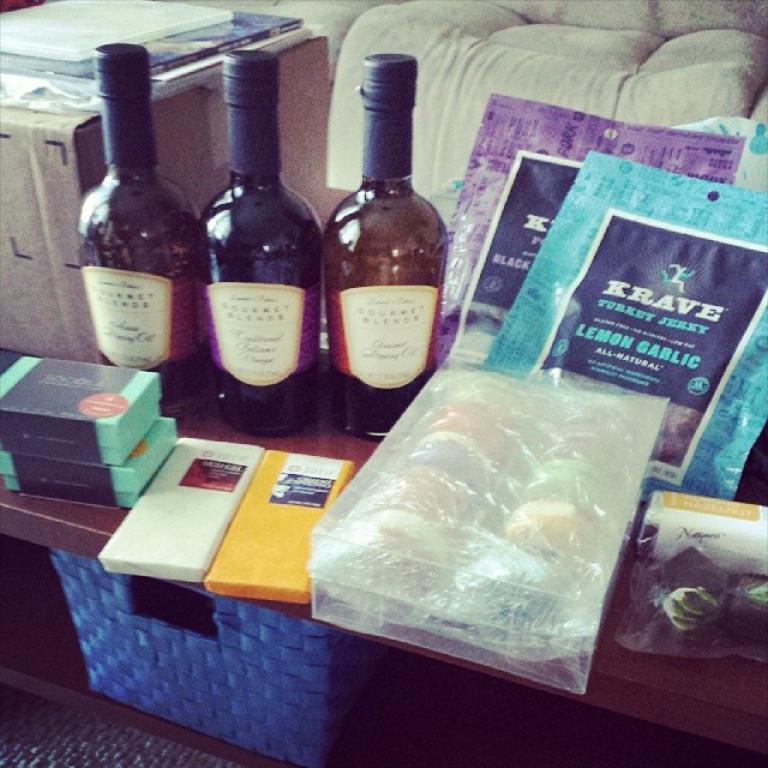<image>
Present a compact description of the photo's key features. Three wine bottles are next to two packages of  Krave jerky. 